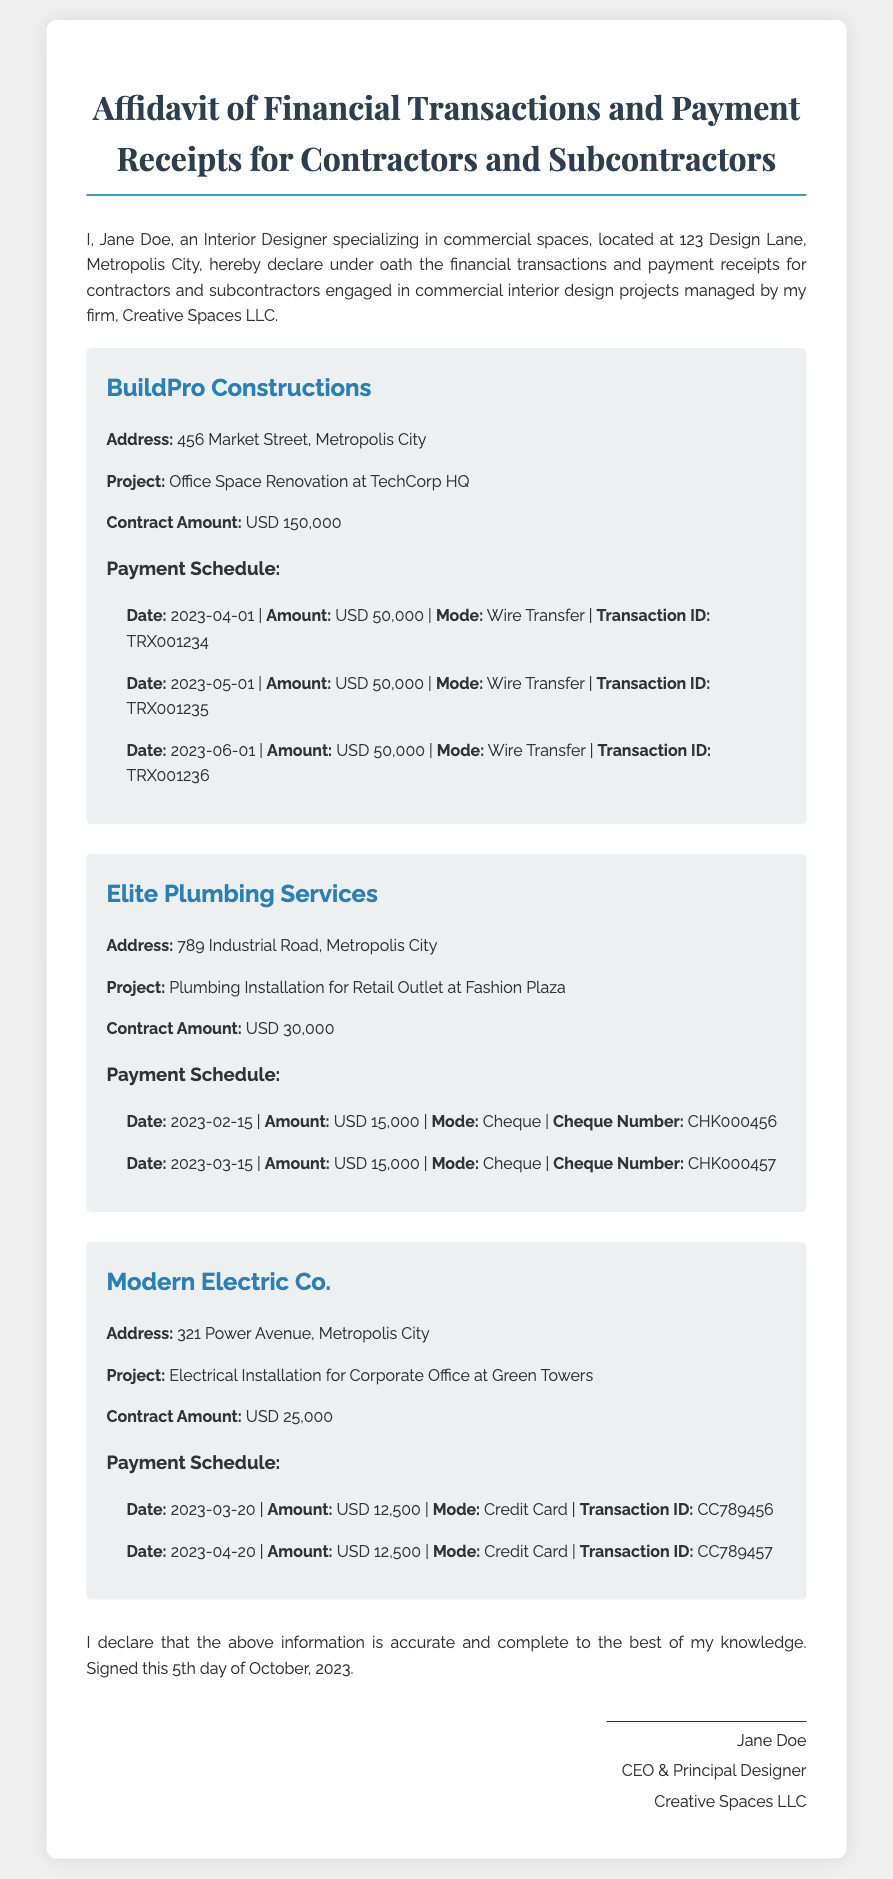What is the name of the interior designer? The interior designer's name is listed at the beginning of the affidavit as Jane Doe.
Answer: Jane Doe What is the total contract amount for BuildPro Constructions? The contract amount for BuildPro Constructions is specified in the document as USD 150,000.
Answer: USD 150,000 How much was paid to Elite Plumbing Services on 2023-02-15? The document states the payment amount made to Elite Plumbing Services on this date is USD 15,000.
Answer: USD 15,000 What mode of payment was used for the last payment to Modern Electric Co.? The last payment's mode for Modern Electric Co. is indicated as Credit Card in the document.
Answer: Credit Card When was the affidavit signed? The date when the affidavit was signed is mentioned as the 5th day of October, 2023.
Answer: 5th day of October, 2023 What project is associated with Elite Plumbing Services? The affidavit details that the project for Elite Plumbing Services is Plumbing Installation for Retail Outlet at Fashion Plaza.
Answer: Plumbing Installation for Retail Outlet at Fashion Plaza How many payments were made to BuildPro Constructions? The document indicates that three payments were made to BuildPro Constructions.
Answer: Three What is the address of Modern Electric Co.? The address of Modern Electric Co. is provided as 321 Power Avenue, Metropolis City.
Answer: 321 Power Avenue, Metropolis City What is the total amount paid to Elite Plumbing Services? The total payments to Elite Plumbing Services add up to USD 30,000, as indicated by two payments of USD 15,000 each.
Answer: USD 30,000 